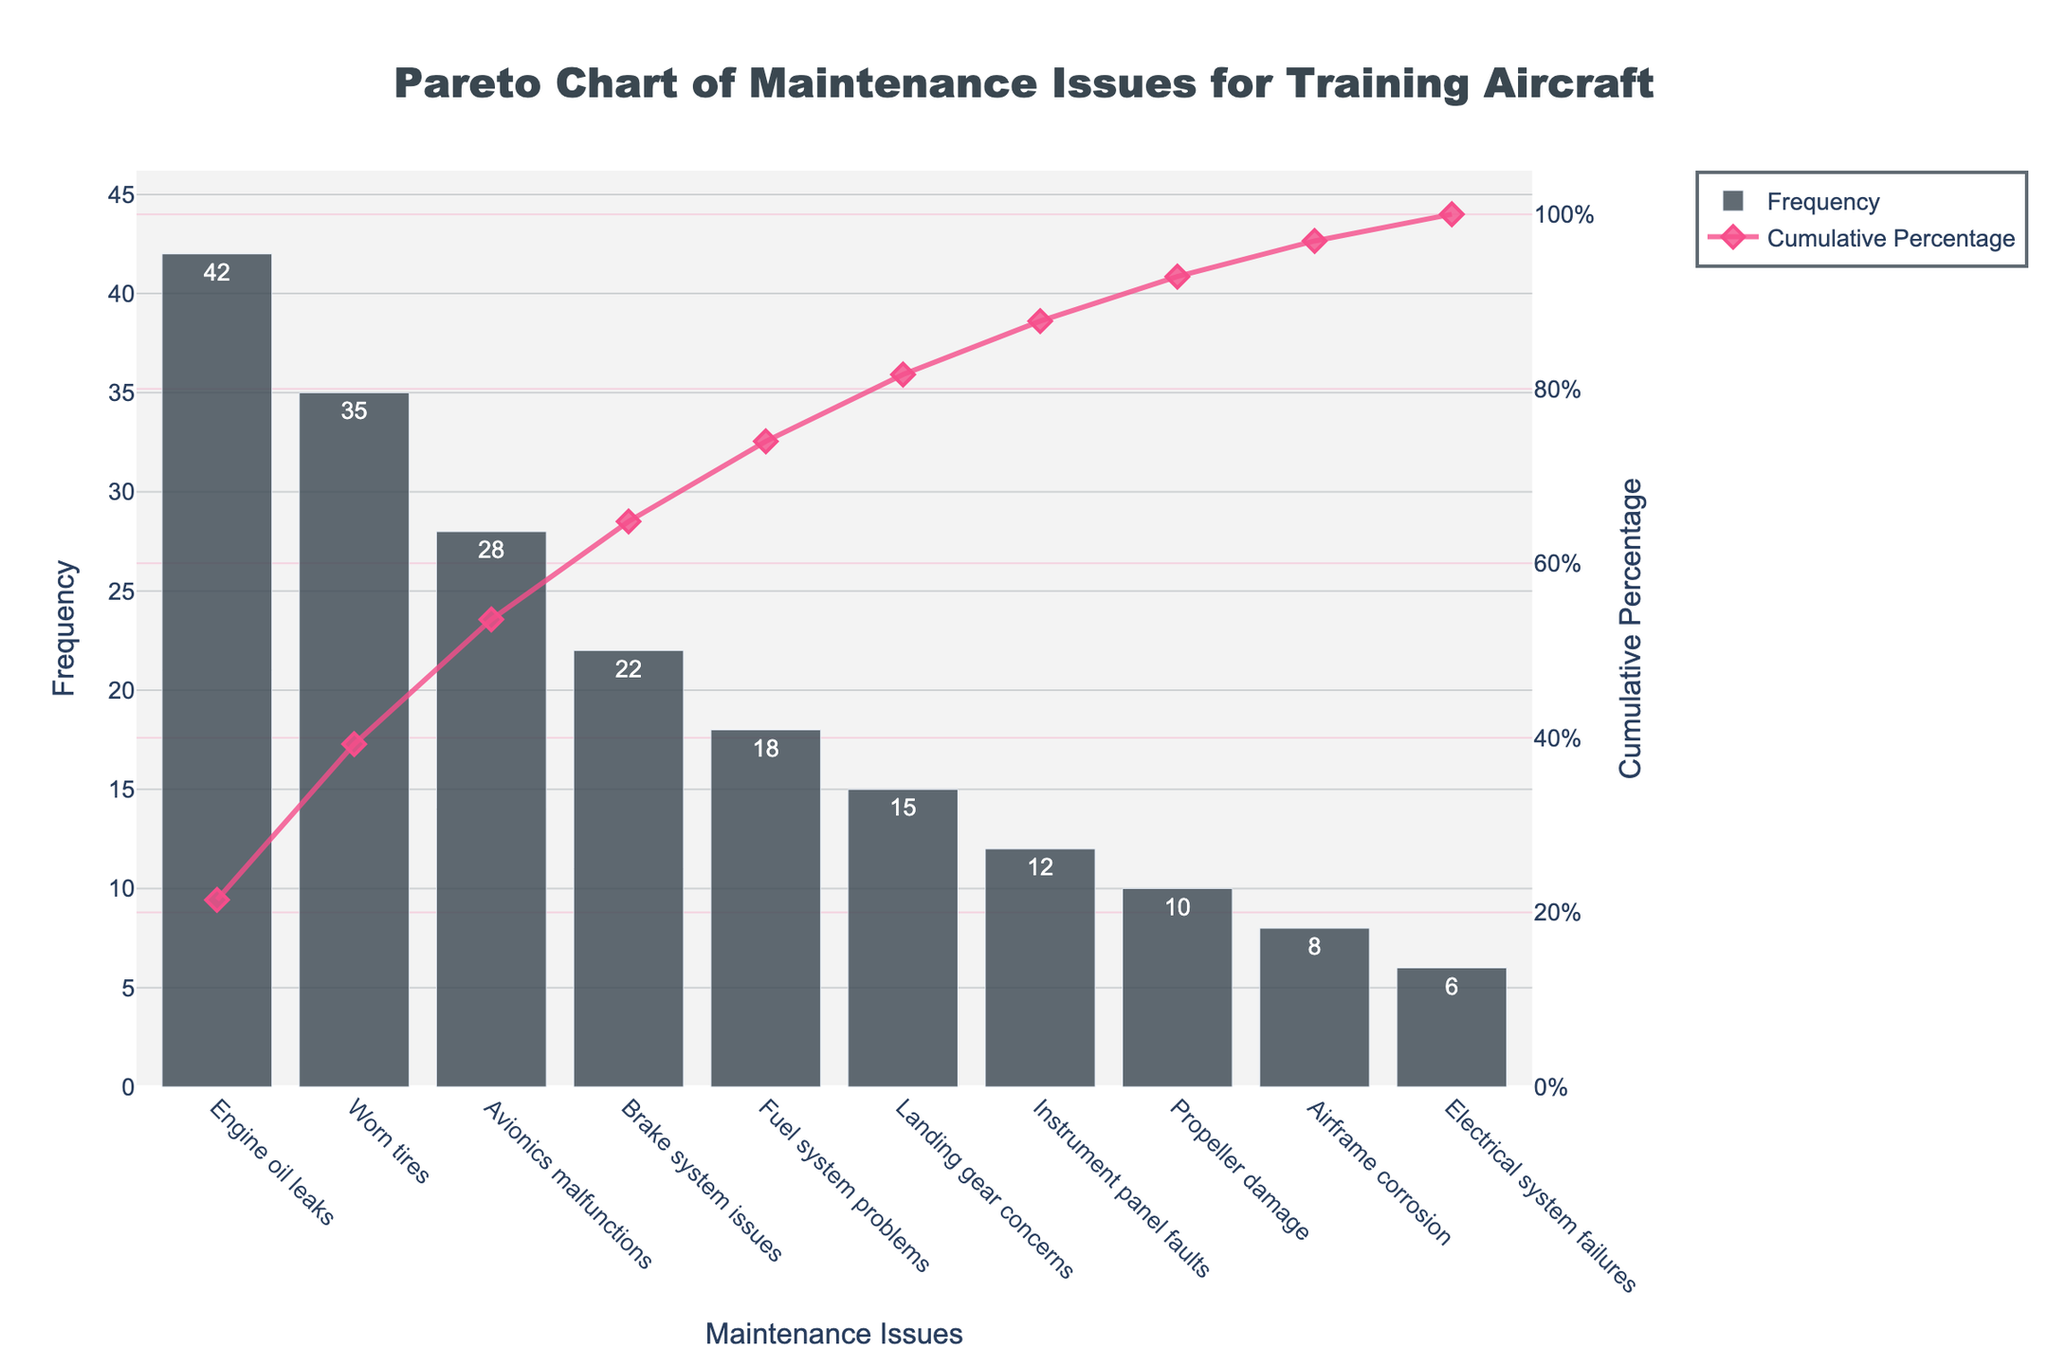What's the title of this chart? The title is mentioned at the top of the chart in bold and larger font size. It helps to understand the main topic of the chart.
Answer: "Pareto Chart of Maintenance Issues for Training Aircraft" Which maintenance issue has the highest frequency? By observing the bar chart, the first bar on the x-axis, which is the tallest, represents the maintenance issue with the highest frequency.
Answer: Engine oil leaks How many issues have a frequency greater than or equal to 20? Look at the bars that reach or surpass the 20 value on the y-axis. Count these bars. There are bars for Engine oil leaks, Worn tires, Avionics malfunctions, Brake system issues.
Answer: 4 What's the cumulative percentage of the first three issues? To find the cumulative percentage for the first three issues, you look at the cumulative percentage line where it coincides with the first, second, and third issue on the x-axis. Cumulative percentages for the first three issues are 36.5%, 66.3%, and 90.7%.
Answer: 90.7% What is the cumulative percentage when you fix the top three issues? The cumulative percentage for the top three issues, found by referencing the line chart, is 90.7%.
Answer: 90.7% Which issue contributes least to the overall maintenance problems? The last bar on the chart represents the issue with the lowest frequency. This bar corresponds to Electrical system failures.
Answer: Electrical system failures How many issues account for at least 80% of the cumulative percentage? Observing the line chart and finding where it crosses the 80% cumulative percentage mark on the y-axis, and counting the corresponding number of issues on the x-axis. The issues are Engine oil leaks, Worn tires, Avionics malfunctions, Brake system issues, and Fuel system problems.
Answer: 5 What is the height of the bar representing Landing gear concerns? The height of the bar directly corresponds to the frequency number listed on the y-axis. For Landing gear concerns, the bar stops at 15.
Answer: 15 What percentage does Airframe corrosion contribute to the total maintenance issues? Find the frequency for Airframe corrosion and divide it by the total frequency sum, then multiply by 100 to get the percentage. The frequency for Airframe corrosion is 8, and the total sum of frequencies is 196. So, (8/196) * 100 = 4.1%.
Answer: 4.1% Compare the frequencies of Worn tires and Avionics malfunctions. Which one is higher and by how much? Worn tires have a frequency of 35 and Avionics malfunctions have a frequency of 28. The difference between them, 35 - 28 = 7.
Answer: Worn tires are higher by 7 